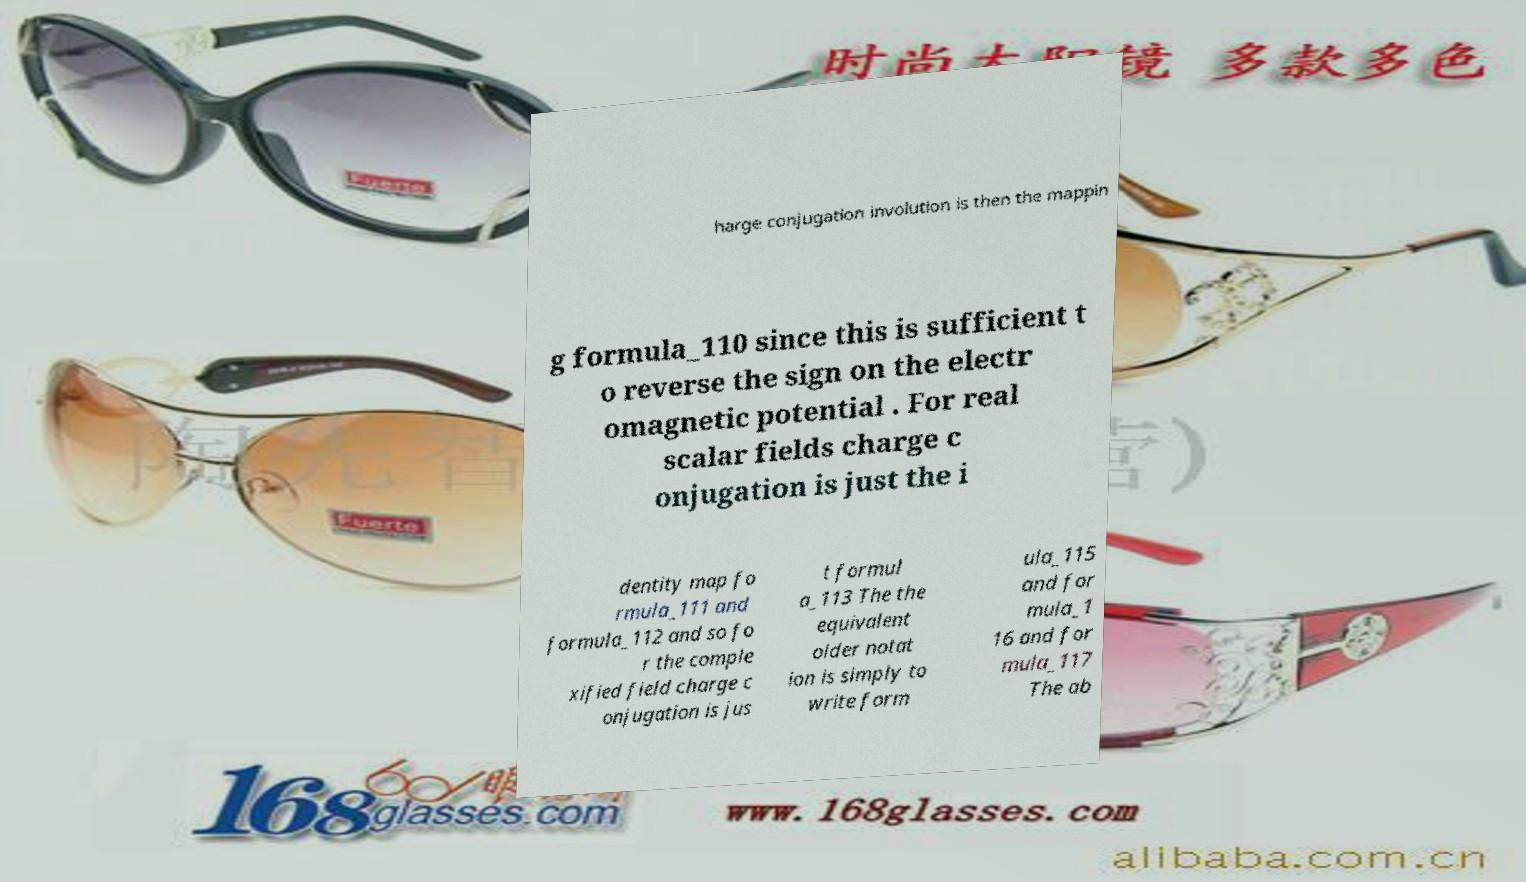There's text embedded in this image that I need extracted. Can you transcribe it verbatim? harge conjugation involution is then the mappin g formula_110 since this is sufficient t o reverse the sign on the electr omagnetic potential . For real scalar fields charge c onjugation is just the i dentity map fo rmula_111 and formula_112 and so fo r the comple xified field charge c onjugation is jus t formul a_113 The the equivalent older notat ion is simply to write form ula_115 and for mula_1 16 and for mula_117 The ab 